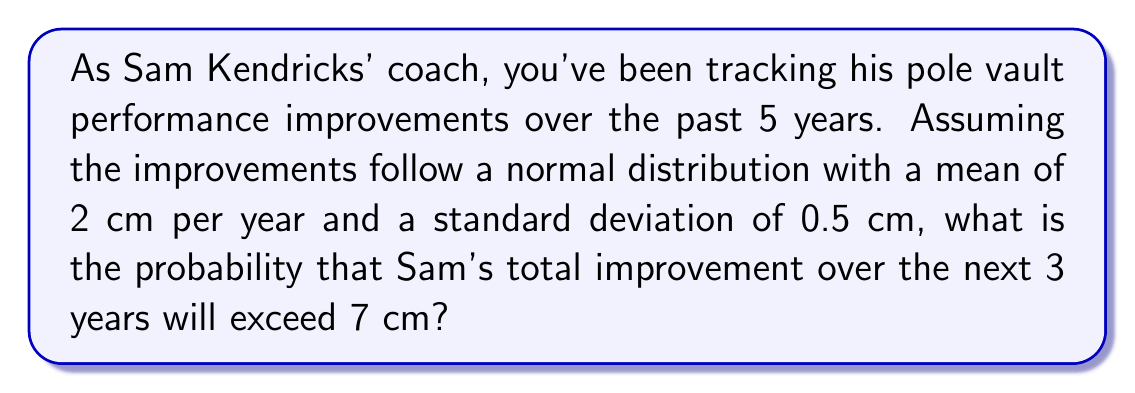Can you solve this math problem? Let's approach this step-by-step:

1) First, we need to determine the distribution of the total improvement over 3 years:

   - Mean improvement per year: $\mu = 2$ cm
   - Standard deviation per year: $\sigma = 0.5$ cm
   - Number of years: $n = 3$

2) For independent normal distributions, when we sum them:
   - The means add
   - The variances add (which means standard deviations are squared, added, then square-rooted)

3) So, for 3 years:
   - Total mean: $\mu_{total} = 3 \times 2 = 6$ cm
   - Total variance: $\sigma_{total}^2 = 3 \times 0.5^2 = 0.75$ cm²
   - Total standard deviation: $\sigma_{total} = \sqrt{0.75} \approx 0.866$ cm

4) We want to find $P(X > 7)$ where $X \sim N(6, 0.866^2)$

5) Standardizing this:
   $$Z = \frac{X - \mu}{\sigma} = \frac{7 - 6}{0.866} \approx 1.155$$

6) We need to find $P(Z > 1.155)$

7) Using a standard normal table or calculator:
   $P(Z > 1.155) \approx 0.1241$

Therefore, the probability that Sam's total improvement over the next 3 years will exceed 7 cm is approximately 0.1241 or 12.41%.
Answer: 0.1241 